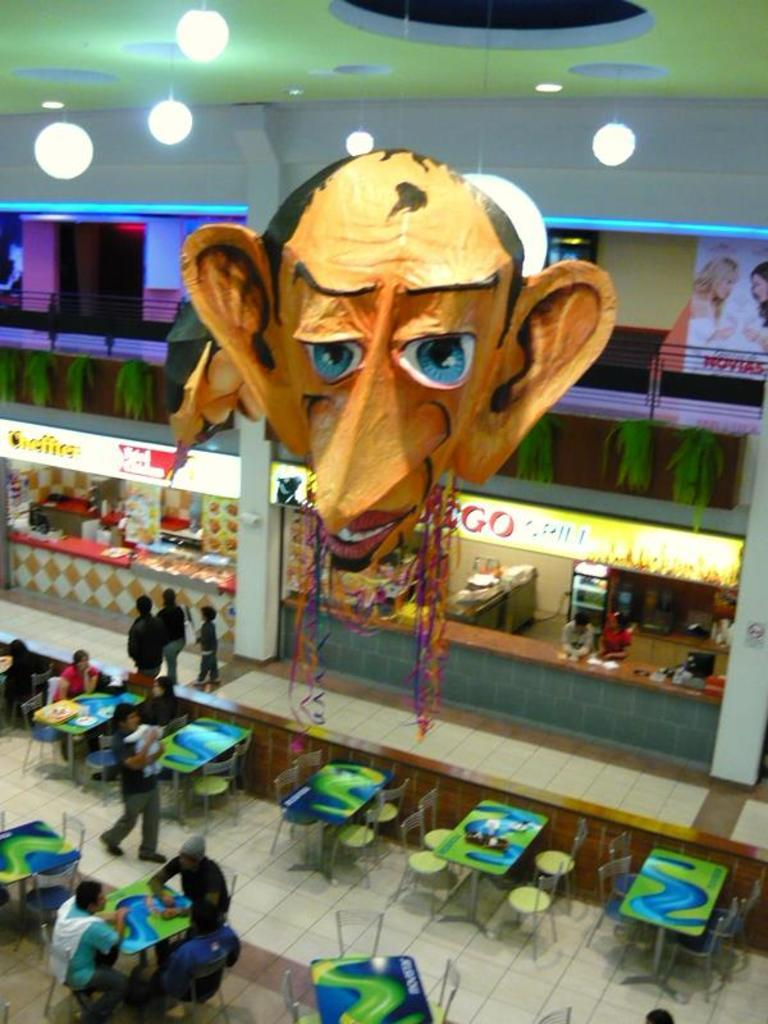How many people are in the image? There are three people in the image. What are the people doing in the image? The people are sitting on a chair and having a conversation. What can be seen above the people in the image? There is a roof in the image, and there is a lighting arrangement on the roof. What type of celery is being used as a prop in the conversation? There is no celery present in the image, and it is not being used as a prop in the conversation. 